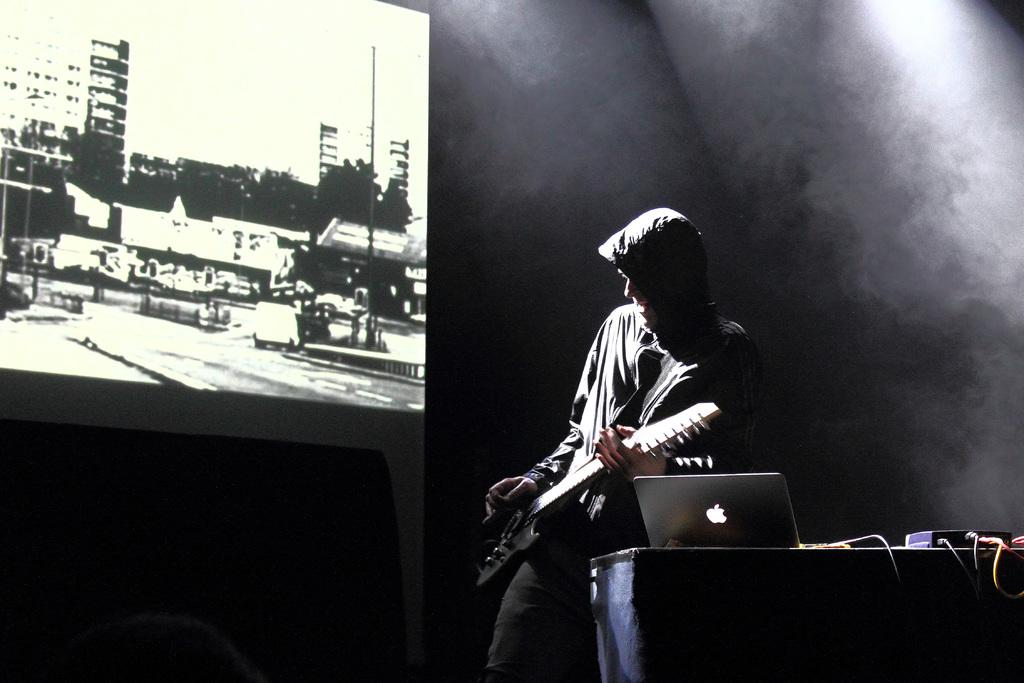What is the man in the image doing? The man is playing the guitar in the image. What object is beside the man? There is a laptop beside the man. What can be seen on the left side of the image? There is a projected image on the left side of the image. What type of spark can be seen coming from the guitar in the image? There is no spark coming from the guitar in the image. What account is the man trying to access on the laptop? The image does not provide information about the man's laptop usage or any accounts he might be trying to access. 